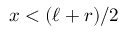Convert formula to latex. <formula><loc_0><loc_0><loc_500><loc_500>x < ( \ell + r ) / 2</formula> 